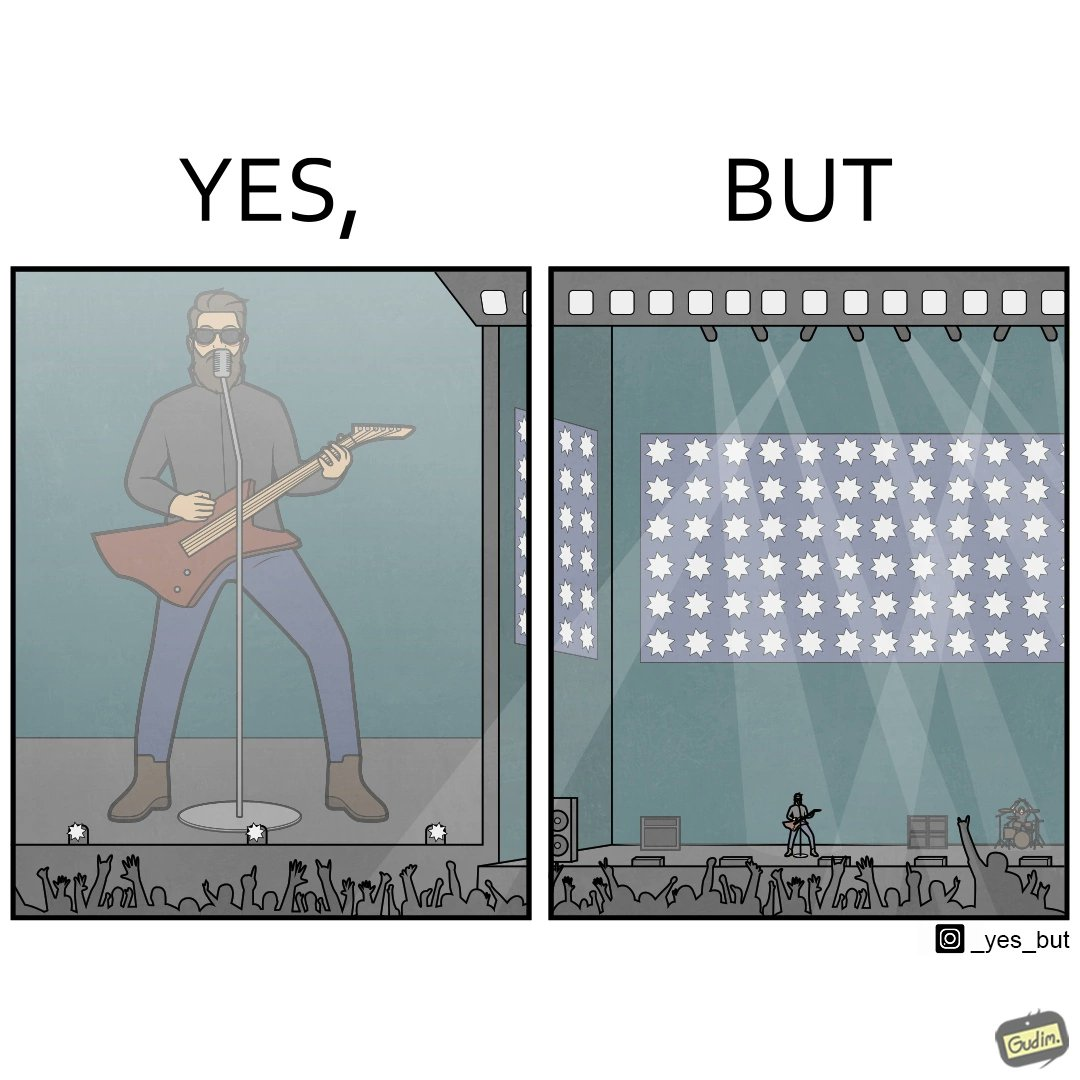Explain the humor or irony in this image. The image is ironic, because as the singer is performing in an orchestra but because there is so much crowd people at the back are not able to get a clear view of the singer 